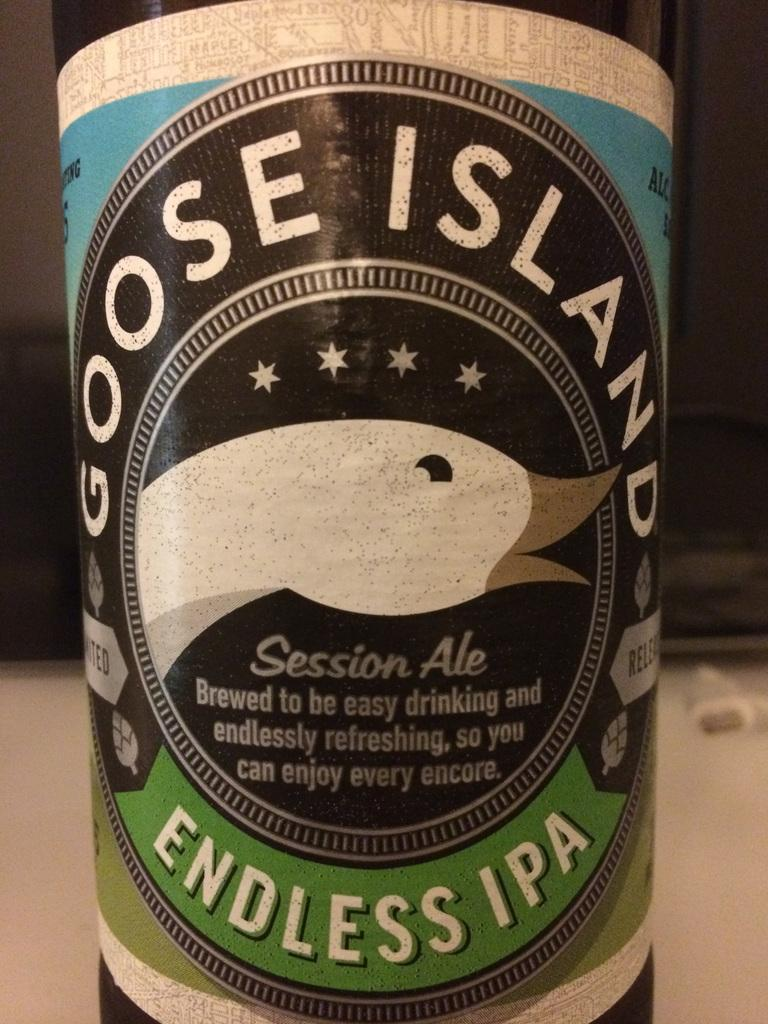<image>
Offer a succinct explanation of the picture presented. A large bottle of Goose Island Endless IPA with a duck on the label. 